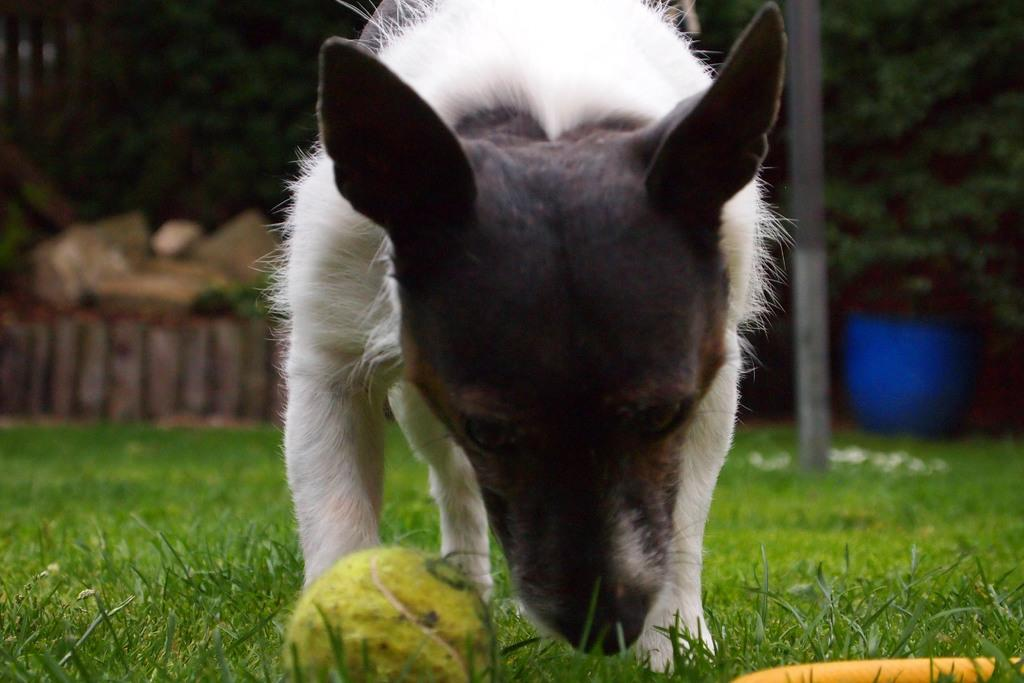What animal can be seen in the image? There is a dog in the image. What object is in front of the dog? There is a ball in front of the dog. Can you describe the background of the image? The background of the image is blurry, but trees and a pole are visible. What type of harbor can be seen in the image? There is no harbor present in the image; it features a dog with a ball in front of it and a blurry background with trees and a pole. 